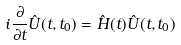<formula> <loc_0><loc_0><loc_500><loc_500>i \frac { \partial } { \partial t } \hat { U } ( t , t _ { 0 } ) = \hat { H } ( t ) \hat { U } ( t , t _ { 0 } )</formula> 